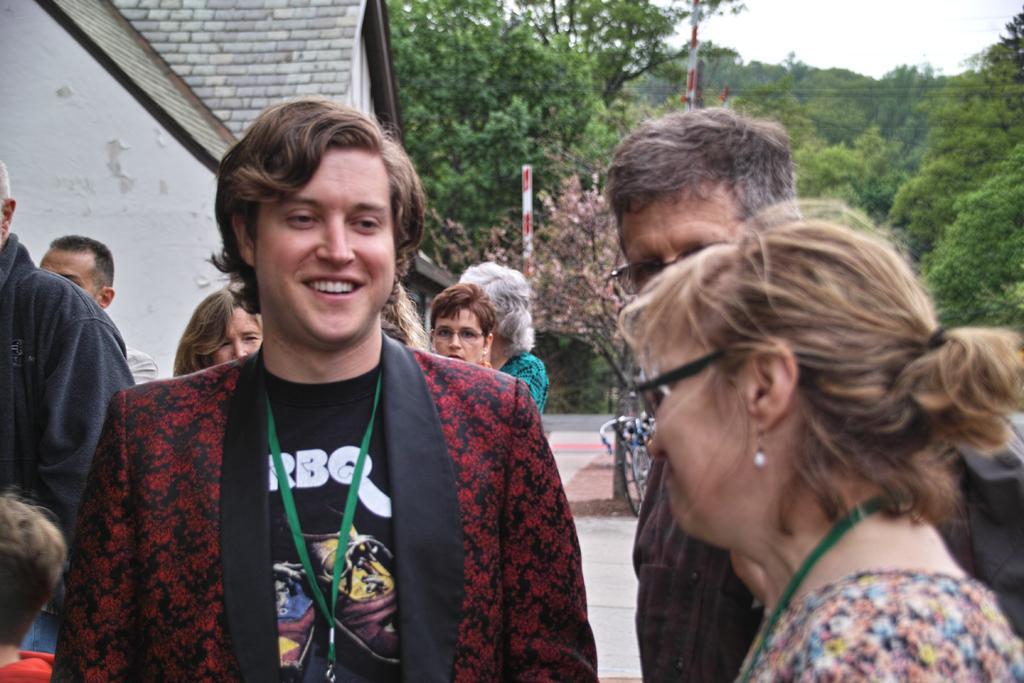What is located in the middle of the image? There are persons and trees in the middle of the image. What can be seen on the left side of the image? There is a building on the left side of the image. What is visible at the top of the image? The sky is visible at the top of the image. Can you read the letter that is being held by the person in the image? There is no letter present in the image; it only features persons, trees, a building, and the sky. What type of pail is being used by the person in the image? There is no pail present in the image; the person is not holding or using any such object. 